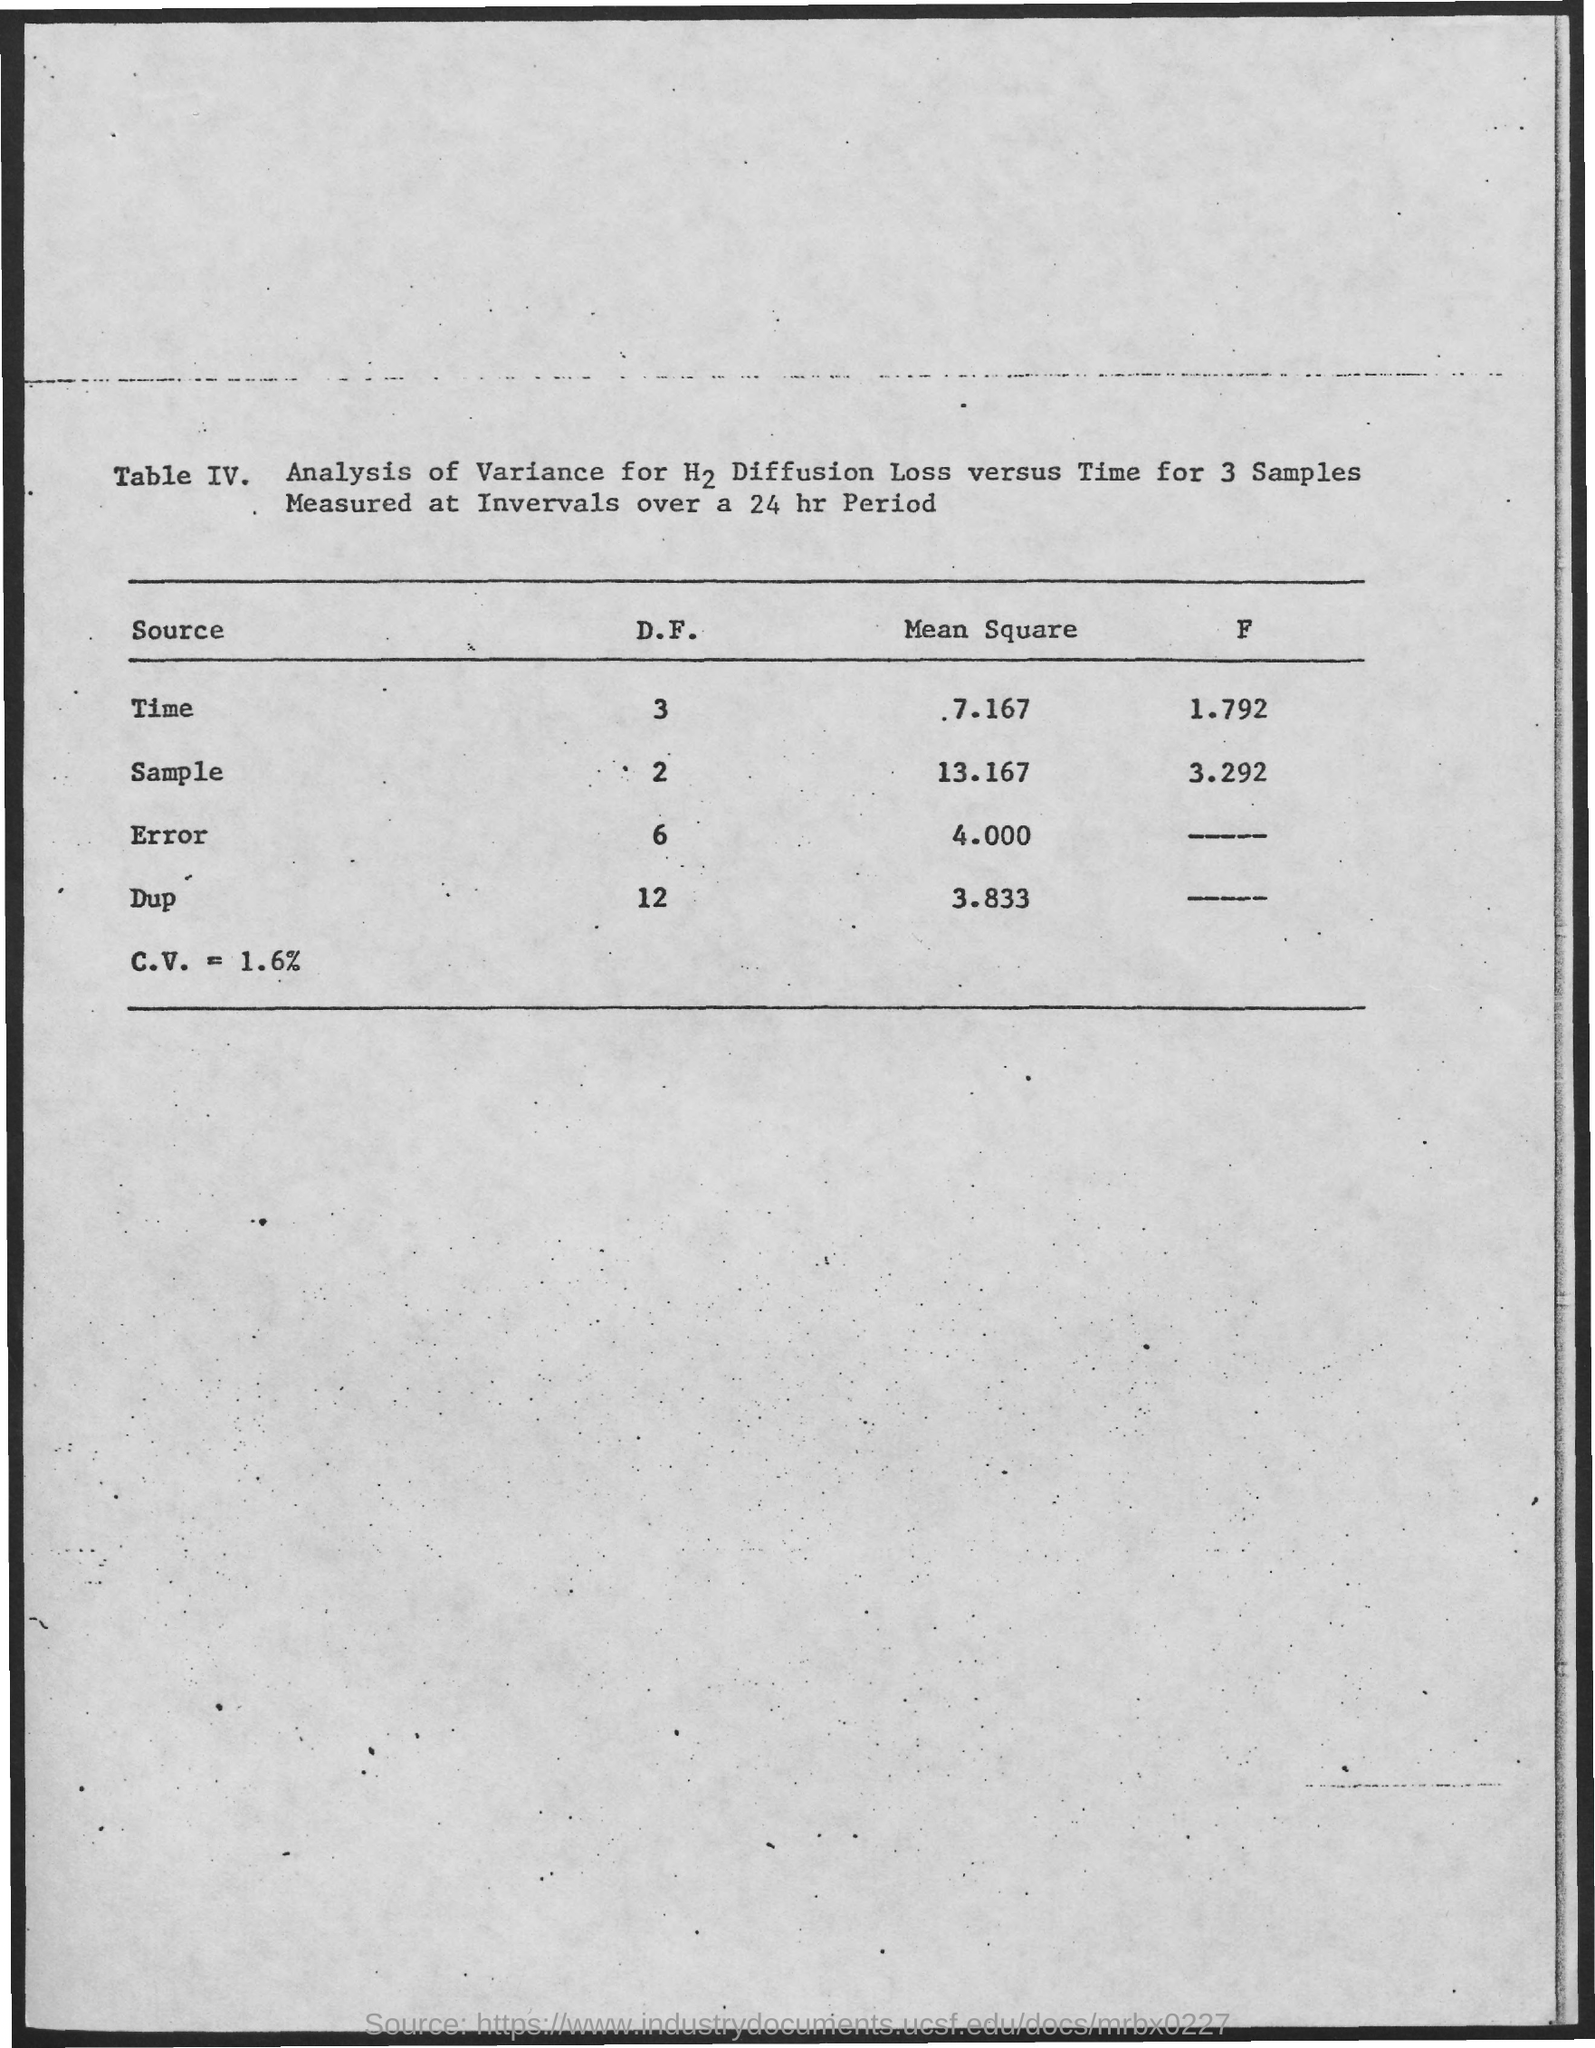Indicate a few pertinent items in this graphic. The mean square error is 4. The mean square for the sample is 13.167... The mean square for Dup is 3.833, indicating that the data points for Dup are relatively spread out and have a high degree of variability. The mean square for time is 7.167... 